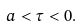Convert formula to latex. <formula><loc_0><loc_0><loc_500><loc_500>a < \tau < 0 .</formula> 